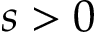<formula> <loc_0><loc_0><loc_500><loc_500>s > 0</formula> 